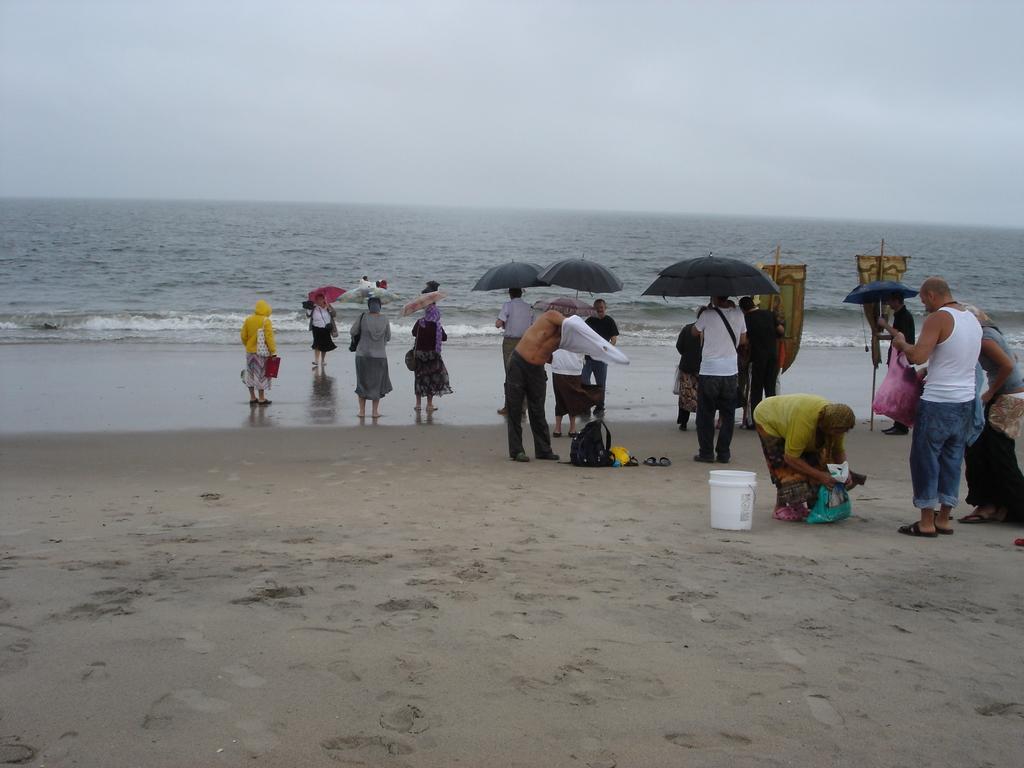Could you give a brief overview of what you see in this image? In this image I can see number of persons standing on the ground and few of them are holding umbrellas which are black in color. I can see a white colored bucket on the ground. In the background I can see the water and the sky. 